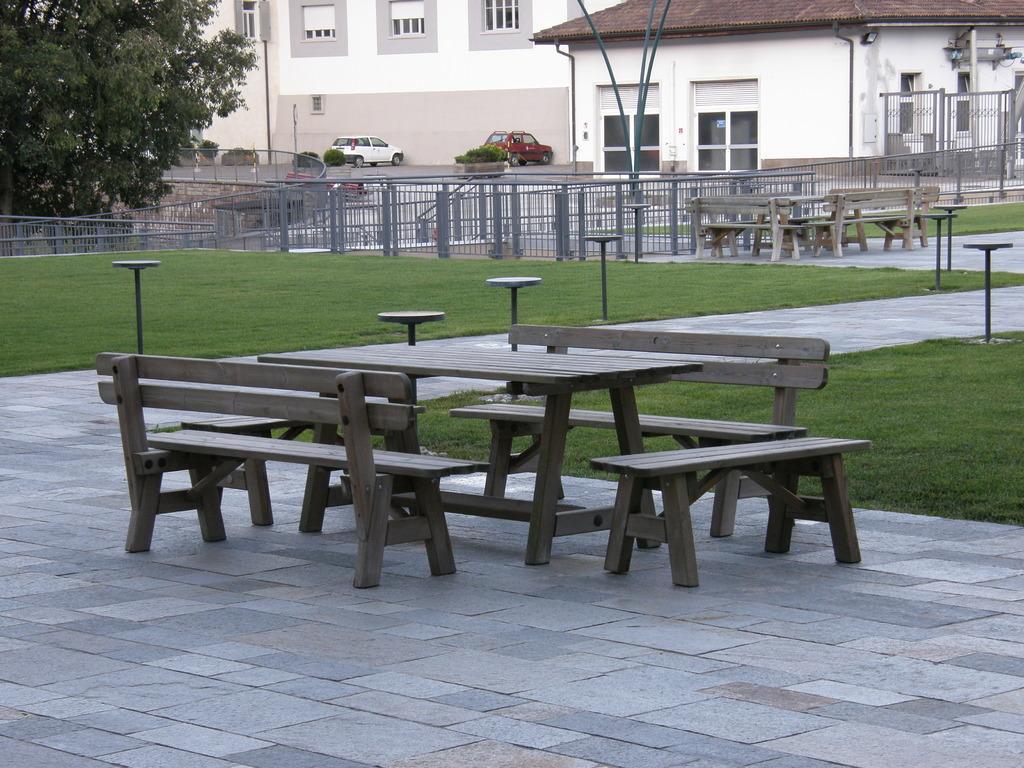Describe this image in one or two sentences. Here we can see benches and tables. Background there are buildings with windows, vehicles, fence, tree and plants. Here we can see grass. 